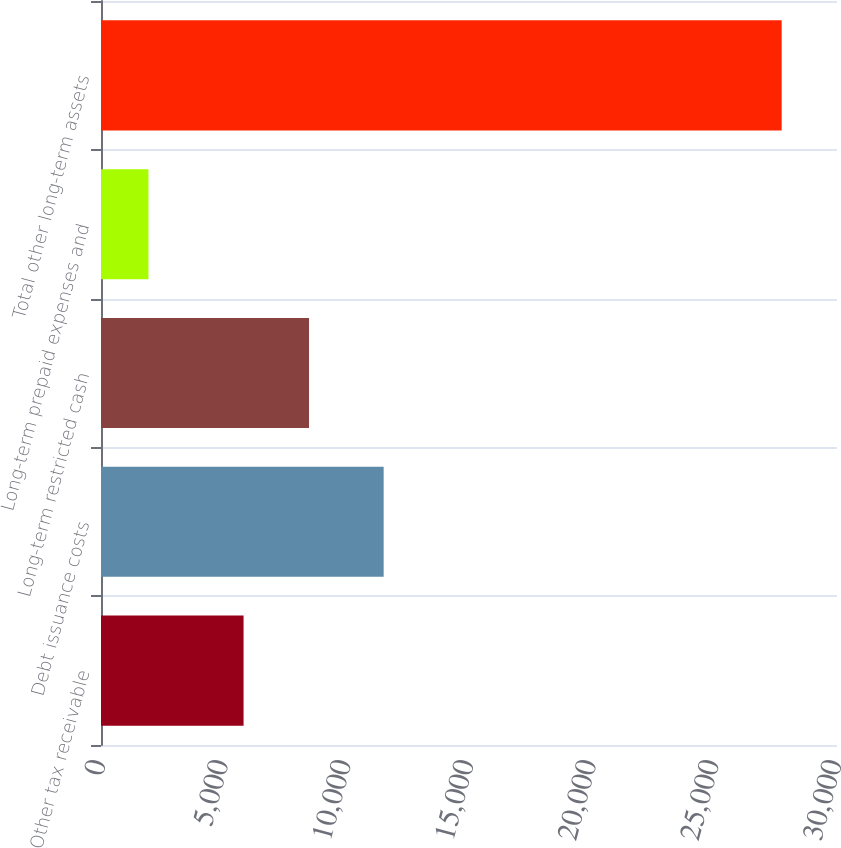Convert chart to OTSL. <chart><loc_0><loc_0><loc_500><loc_500><bar_chart><fcel>Other tax receivable<fcel>Debt issuance costs<fcel>Long-term restricted cash<fcel>Long-term prepaid expenses and<fcel>Total other long-term assets<nl><fcel>5811<fcel>11521<fcel>8479<fcel>1934<fcel>27745<nl></chart> 